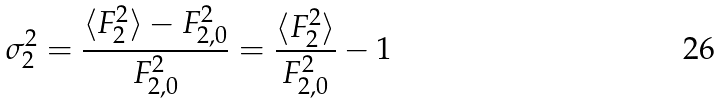Convert formula to latex. <formula><loc_0><loc_0><loc_500><loc_500>\sigma ^ { 2 } _ { 2 } = \frac { \langle F _ { 2 } ^ { 2 } \rangle - F _ { 2 , 0 } ^ { 2 } } { F _ { 2 , 0 } ^ { 2 } } = \frac { \langle F _ { 2 } ^ { 2 } \rangle } { F _ { 2 , 0 } ^ { 2 } } - 1</formula> 